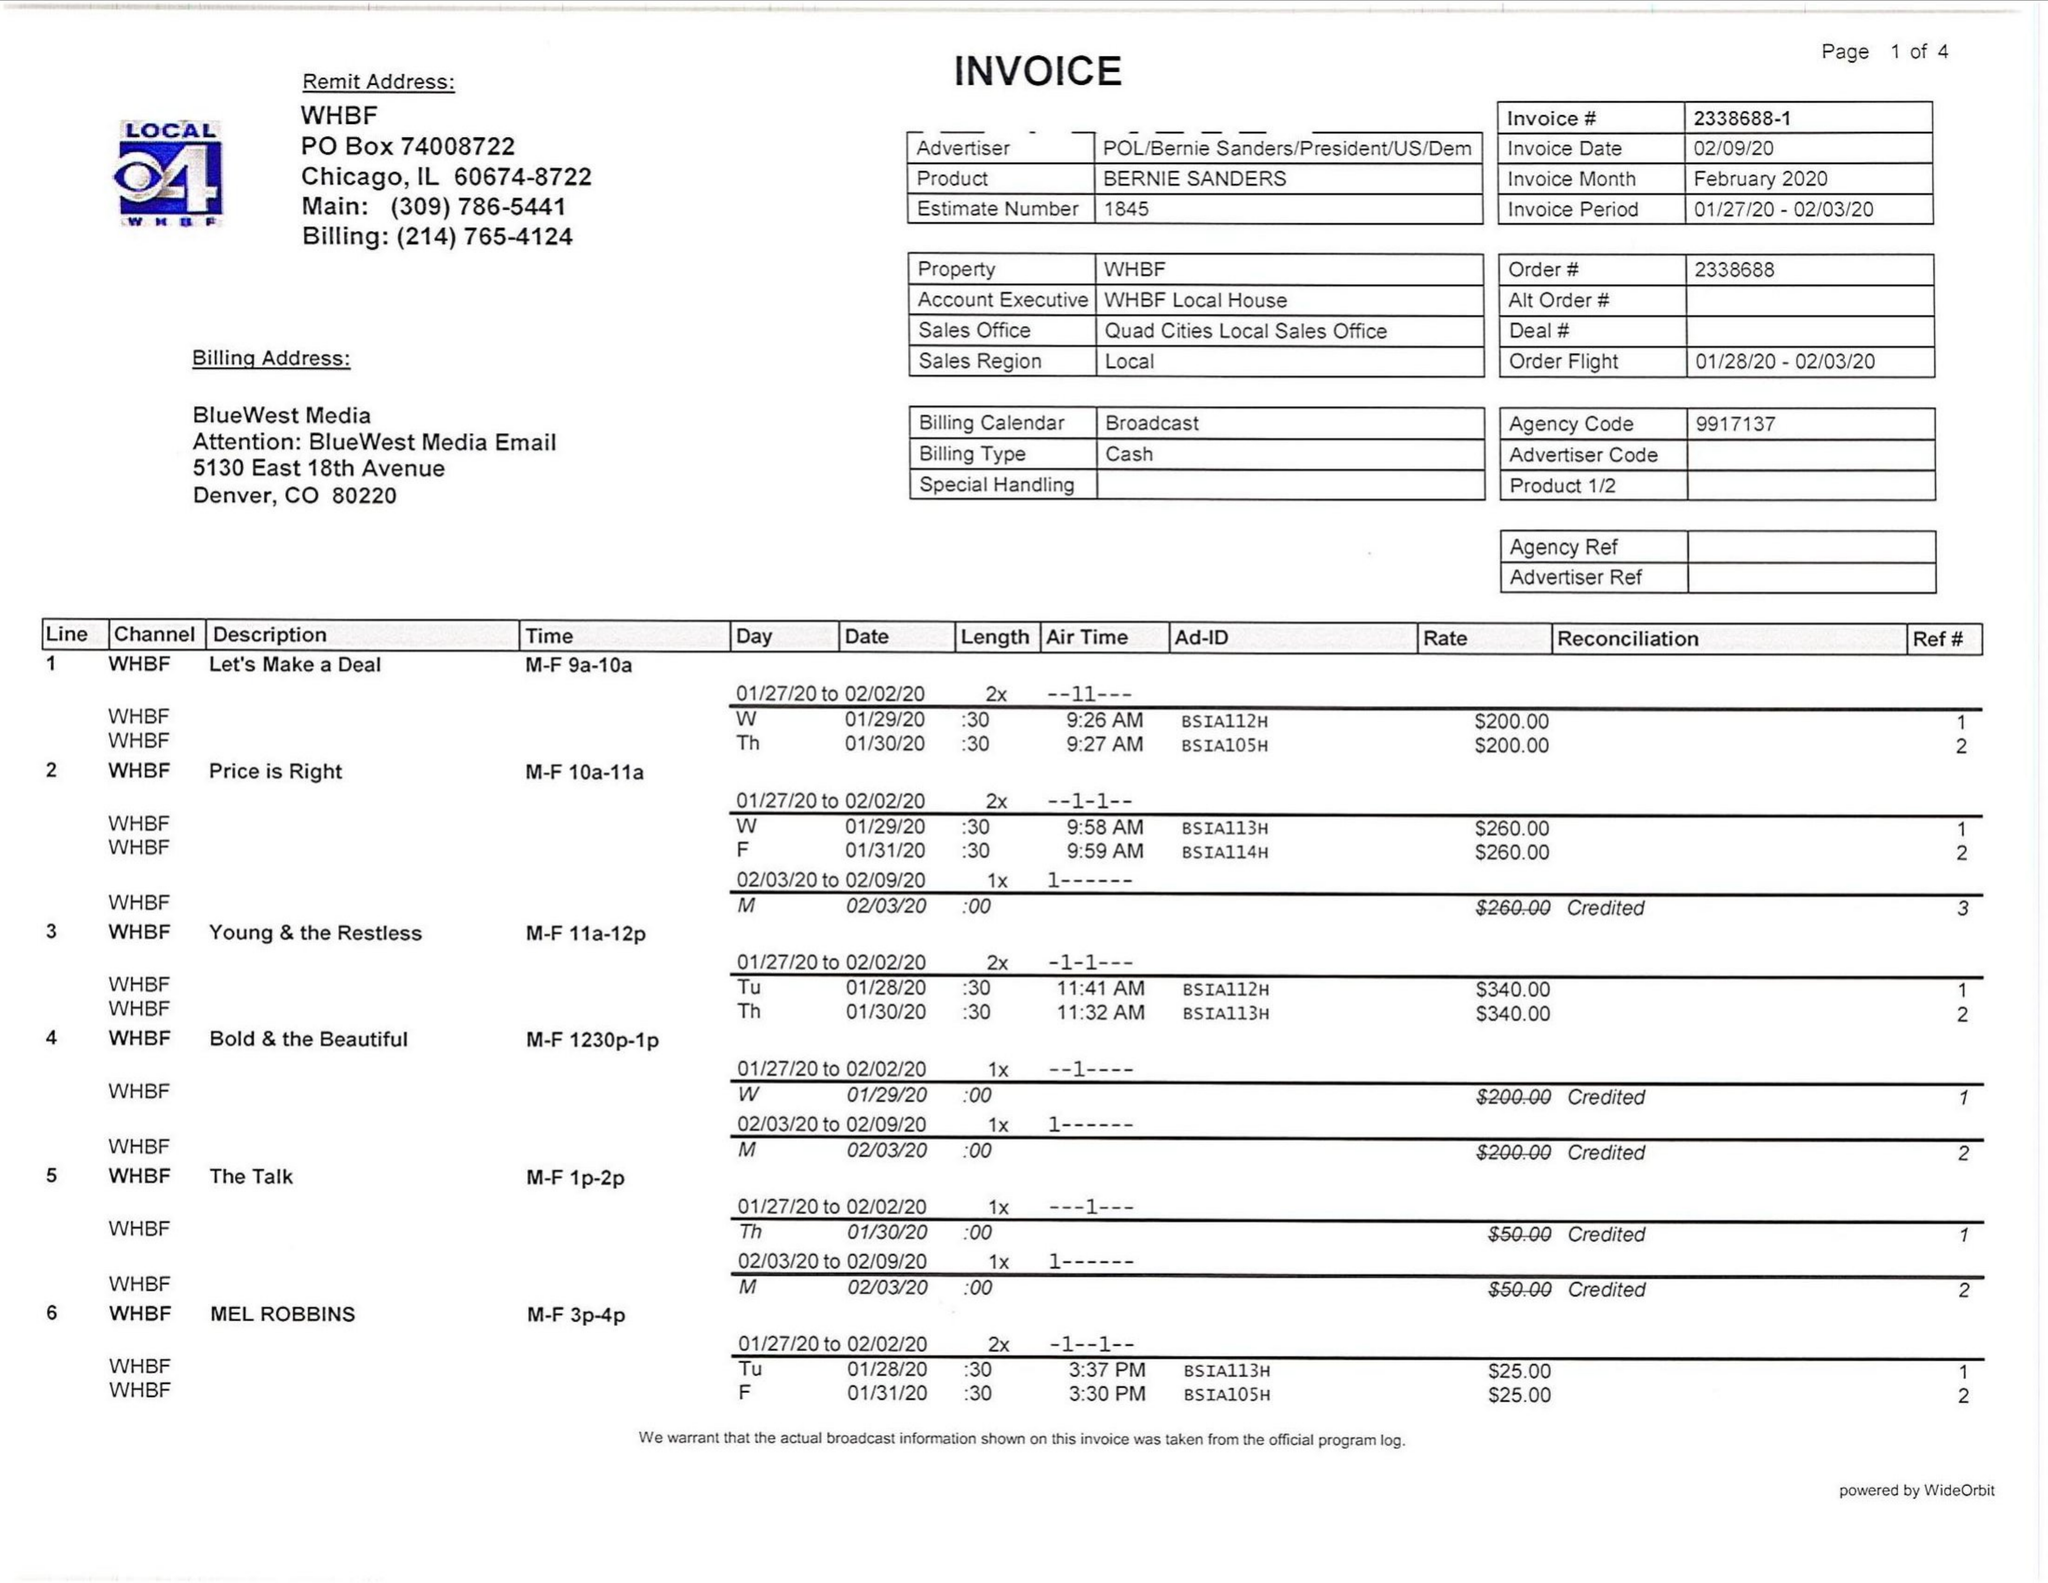What is the value for the contract_num?
Answer the question using a single word or phrase. 2338688 